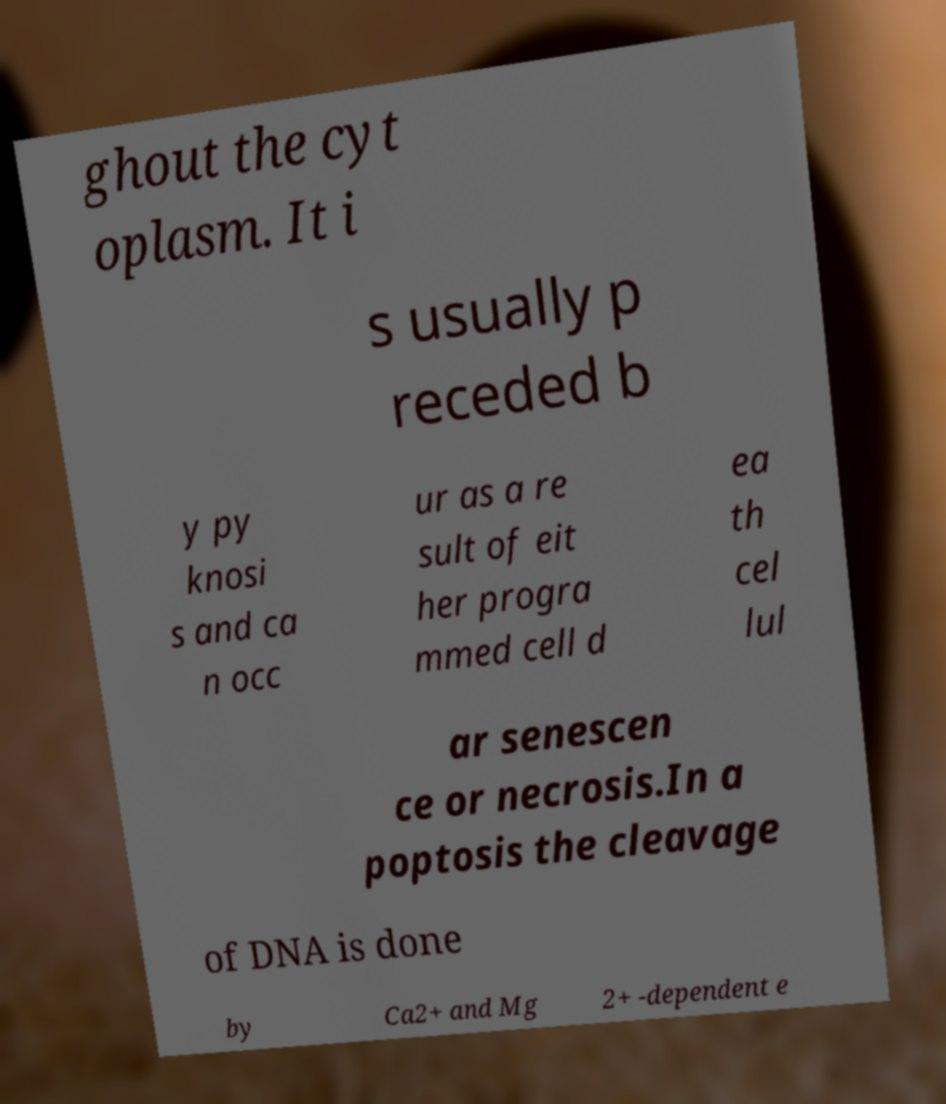I need the written content from this picture converted into text. Can you do that? ghout the cyt oplasm. It i s usually p receded b y py knosi s and ca n occ ur as a re sult of eit her progra mmed cell d ea th cel lul ar senescen ce or necrosis.In a poptosis the cleavage of DNA is done by Ca2+ and Mg 2+ -dependent e 